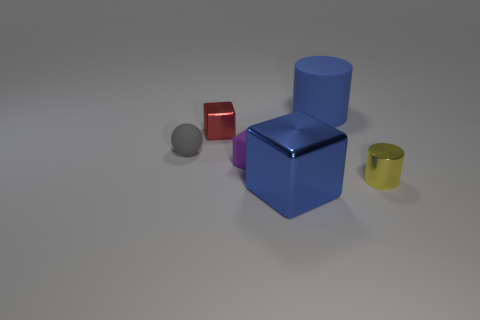What shape is the metal object that is on the left side of the object in front of the small shiny object that is on the right side of the tiny purple cube?
Provide a succinct answer. Cube. Is there anything else that is the same shape as the large matte thing?
Your response must be concise. Yes. How many cylinders are large blue objects or tiny shiny objects?
Provide a short and direct response. 2. Does the small object that is on the right side of the purple rubber block have the same color as the matte block?
Your answer should be compact. No. There is a large blue thing behind the metallic thing on the right side of the large object behind the tiny rubber block; what is it made of?
Your answer should be compact. Rubber. Is the rubber cube the same size as the blue metal thing?
Keep it short and to the point. No. There is a big shiny thing; is its color the same as the cylinder that is behind the tiny red metallic object?
Give a very brief answer. Yes. There is a tiny red object that is made of the same material as the tiny cylinder; what shape is it?
Your answer should be compact. Cube. There is a metallic object that is in front of the yellow shiny cylinder; does it have the same shape as the small purple rubber thing?
Your answer should be compact. Yes. There is a blue object that is left of the rubber thing that is to the right of the big blue block; what is its size?
Offer a very short reply. Large. 